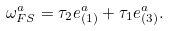Convert formula to latex. <formula><loc_0><loc_0><loc_500><loc_500>\omega _ { F S } ^ { a } = \tau _ { 2 } e _ { ( 1 ) } ^ { a } + \tau _ { 1 } e _ { ( 3 ) } ^ { a } .</formula> 